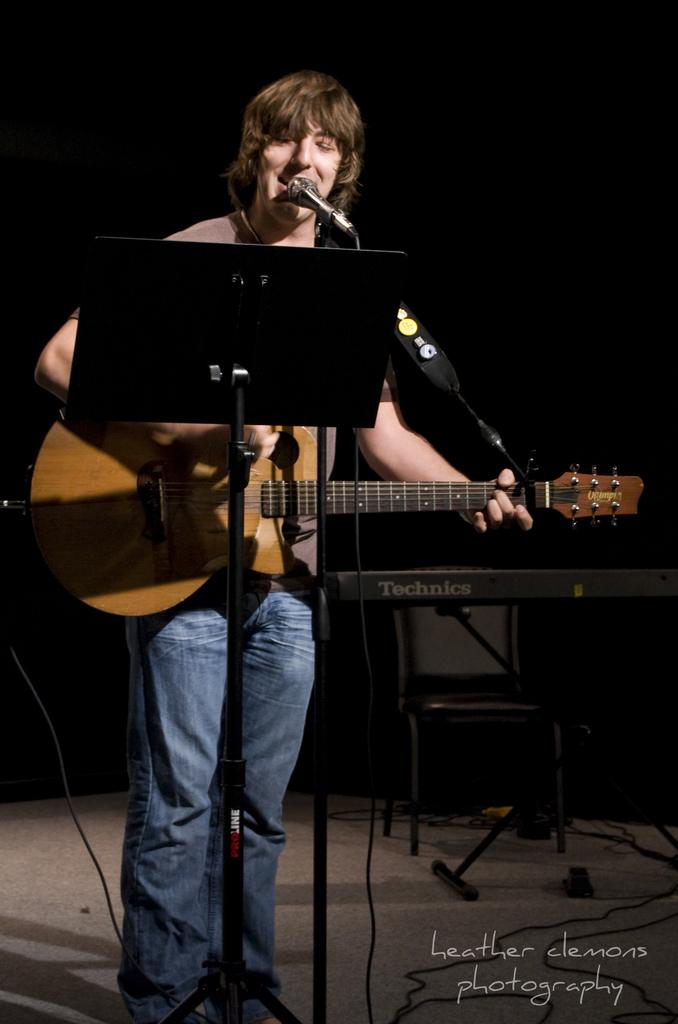What is the person in the image doing? The person is standing, playing a guitar, and singing. What object is the person holding in the image? The person is holding a microphone in the image. Can you see any bats flying around the person in the image? No, there are no bats visible in the image. 